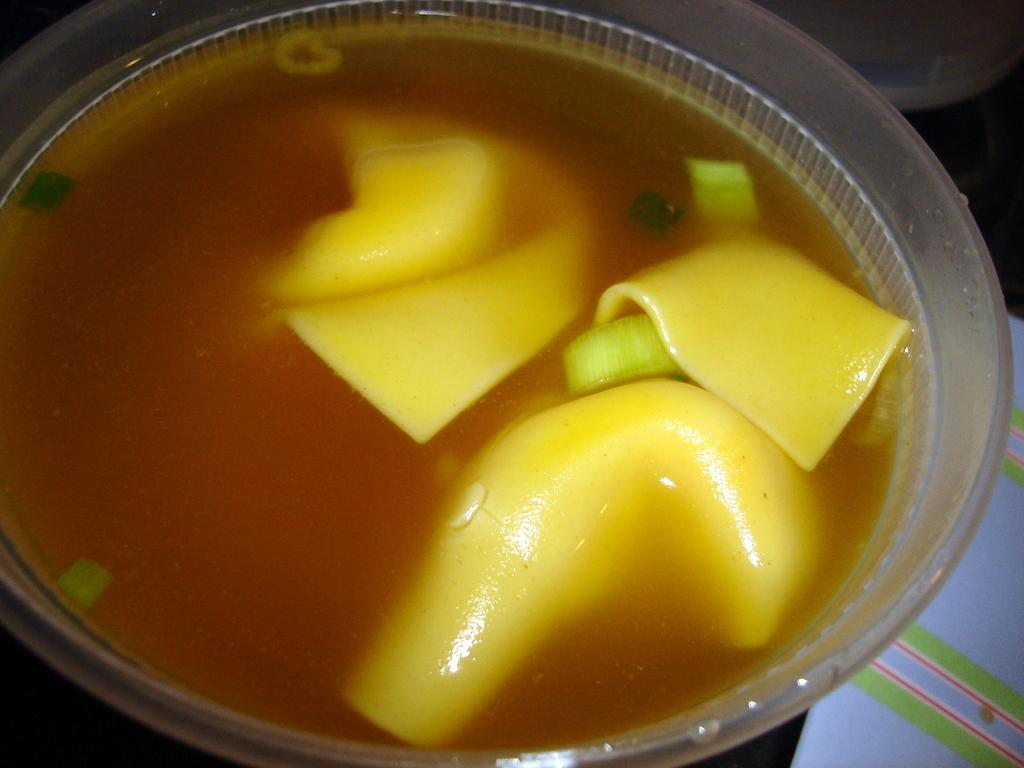What is in the bowl that is visible in the image? There is a bowl of soup in the image. What can be seen inside the soup? The soup contains yellow color objects. What year is depicted on the linen in the image? There is no linen or year mentioned in the image; it only features a bowl of soup with yellow color objects. 